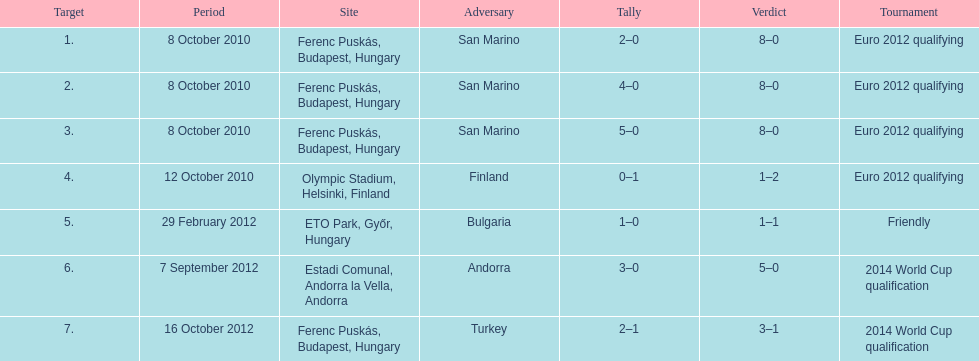How many non-qualifying matches did he manage to score in? 1. 